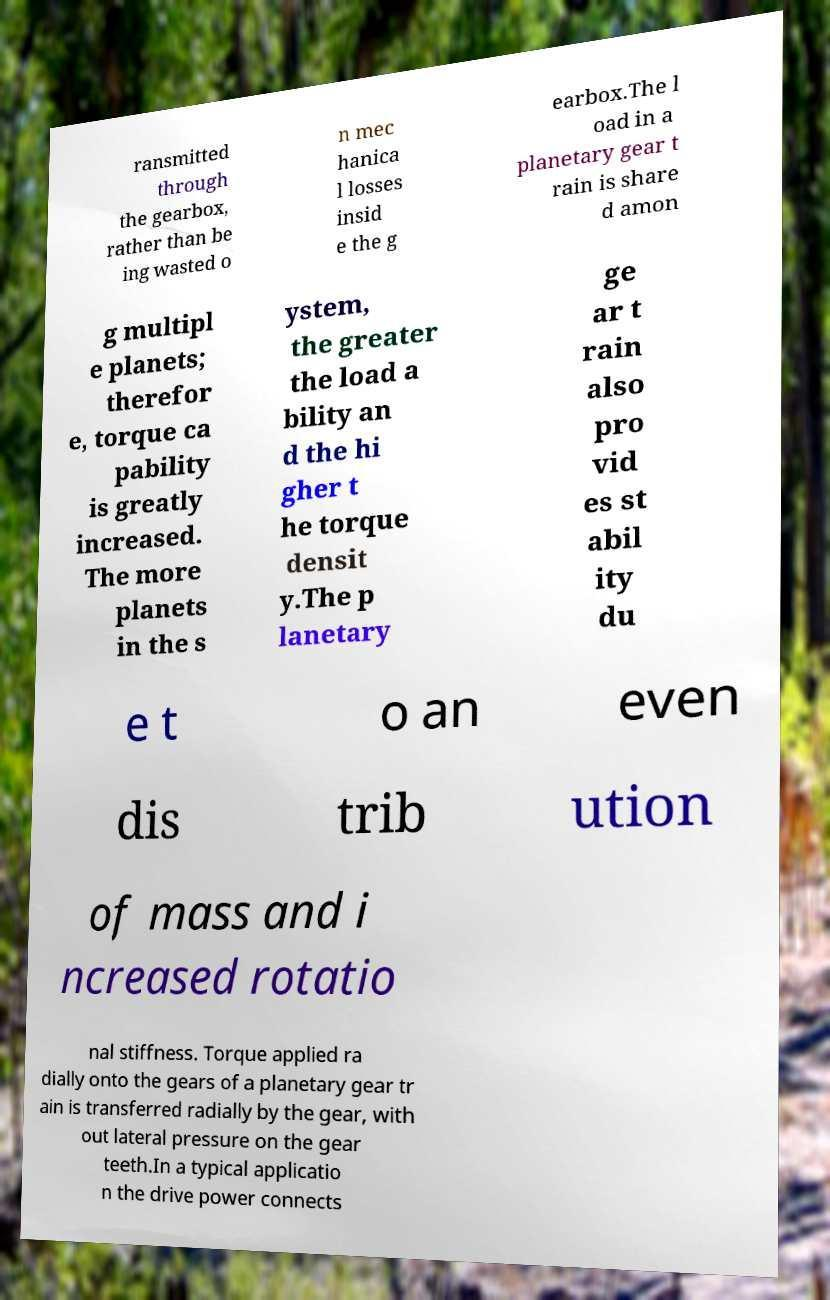What messages or text are displayed in this image? I need them in a readable, typed format. ransmitted through the gearbox, rather than be ing wasted o n mec hanica l losses insid e the g earbox.The l oad in a planetary gear t rain is share d amon g multipl e planets; therefor e, torque ca pability is greatly increased. The more planets in the s ystem, the greater the load a bility an d the hi gher t he torque densit y.The p lanetary ge ar t rain also pro vid es st abil ity du e t o an even dis trib ution of mass and i ncreased rotatio nal stiffness. Torque applied ra dially onto the gears of a planetary gear tr ain is transferred radially by the gear, with out lateral pressure on the gear teeth.In a typical applicatio n the drive power connects 